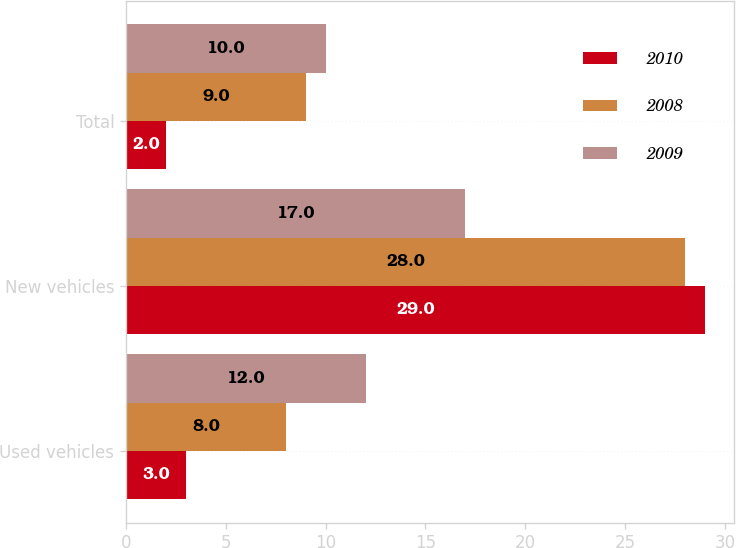Convert chart. <chart><loc_0><loc_0><loc_500><loc_500><stacked_bar_chart><ecel><fcel>Used vehicles<fcel>New vehicles<fcel>Total<nl><fcel>2010<fcel>3<fcel>29<fcel>2<nl><fcel>2008<fcel>8<fcel>28<fcel>9<nl><fcel>2009<fcel>12<fcel>17<fcel>10<nl></chart> 